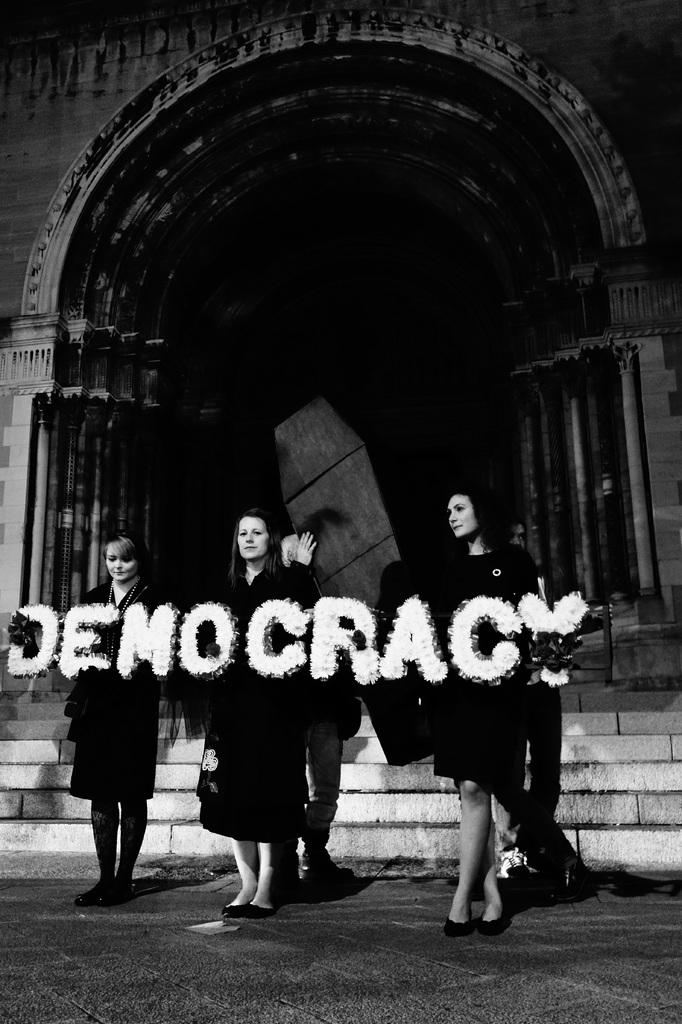What is the color scheme of the image? The image is black and white. What are the women in the image doing? The women are standing on the road and holding decor letters in their hands. What can be seen in the background of the image? There is an arch and stairs in the background of the image. Can you see any flesh-colored objects in the image? There is no reference to any flesh-colored objects in the image, as it is black and white. Are there any squirrels visible in the image? There are no squirrels present in the image. 